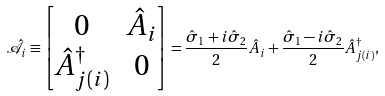Convert formula to latex. <formula><loc_0><loc_0><loc_500><loc_500>\hat { \mathcal { A } } _ { i } \equiv \begin{bmatrix} 0 & \hat { A } _ { i } \\ \hat { A } ^ { \dagger } _ { j ( i ) } & 0 \end{bmatrix} = \frac { \hat { \sigma } _ { 1 } + i \hat { \sigma } _ { 2 } } { 2 } \hat { A } _ { i } + \frac { \hat { \sigma } _ { 1 } - i \hat { \sigma } _ { 2 } } { 2 } \hat { A } ^ { \dagger } _ { j ( i ) } ,</formula> 